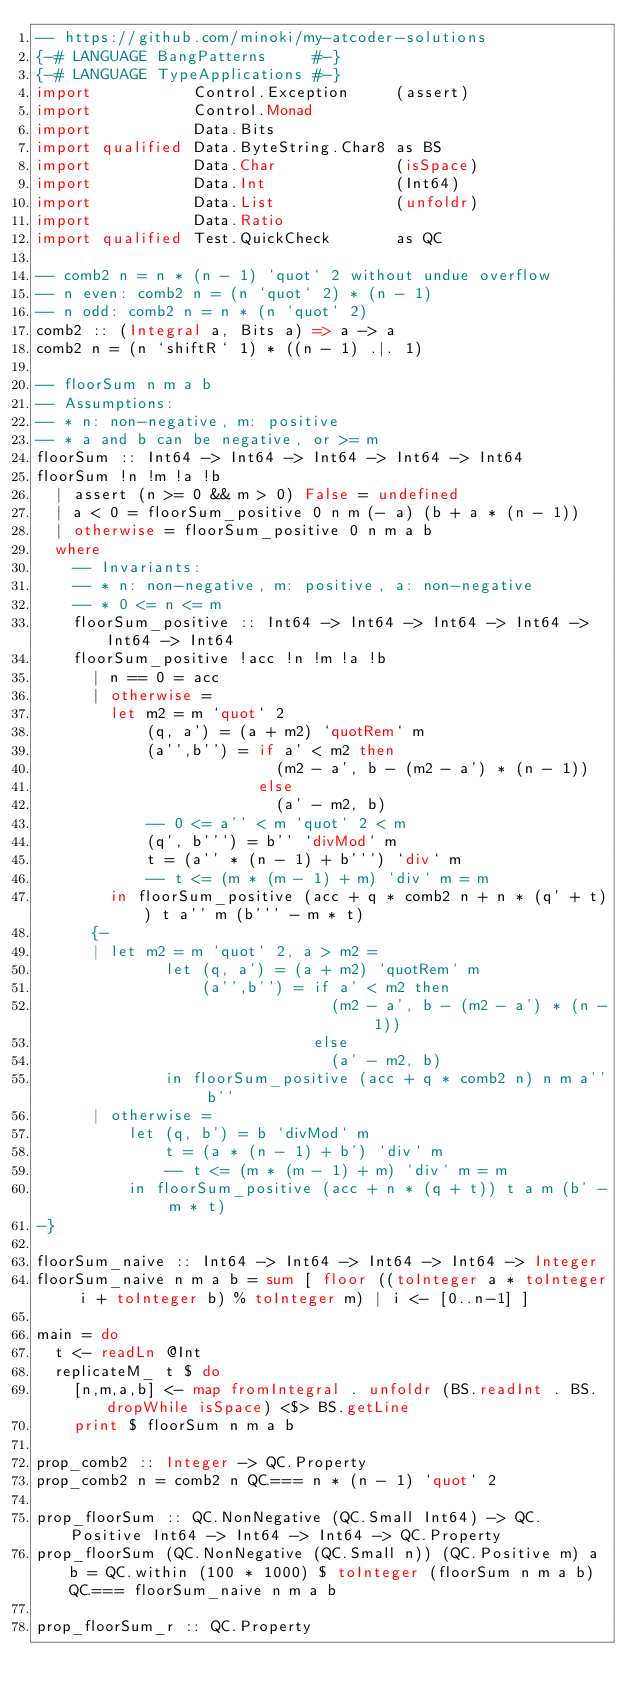<code> <loc_0><loc_0><loc_500><loc_500><_Haskell_>-- https://github.com/minoki/my-atcoder-solutions
{-# LANGUAGE BangPatterns     #-}
{-# LANGUAGE TypeApplications #-}
import           Control.Exception     (assert)
import           Control.Monad
import           Data.Bits
import qualified Data.ByteString.Char8 as BS
import           Data.Char             (isSpace)
import           Data.Int              (Int64)
import           Data.List             (unfoldr)
import           Data.Ratio
import qualified Test.QuickCheck       as QC

-- comb2 n = n * (n - 1) `quot` 2 without undue overflow
-- n even: comb2 n = (n `quot` 2) * (n - 1)
-- n odd: comb2 n = n * (n `quot` 2)
comb2 :: (Integral a, Bits a) => a -> a
comb2 n = (n `shiftR` 1) * ((n - 1) .|. 1)

-- floorSum n m a b
-- Assumptions:
-- * n: non-negative, m: positive
-- * a and b can be negative, or >= m
floorSum :: Int64 -> Int64 -> Int64 -> Int64 -> Int64
floorSum !n !m !a !b
  | assert (n >= 0 && m > 0) False = undefined
  | a < 0 = floorSum_positive 0 n m (- a) (b + a * (n - 1))
  | otherwise = floorSum_positive 0 n m a b
  where
    -- Invariants:
    -- * n: non-negative, m: positive, a: non-negative
    -- * 0 <= n <= m
    floorSum_positive :: Int64 -> Int64 -> Int64 -> Int64 -> Int64 -> Int64
    floorSum_positive !acc !n !m !a !b
      | n == 0 = acc
      | otherwise =
        let m2 = m `quot` 2
            (q, a') = (a + m2) `quotRem` m
            (a'',b'') = if a' < m2 then
                          (m2 - a', b - (m2 - a') * (n - 1))
                        else
                          (a' - m2, b)
            -- 0 <= a'' < m `quot` 2 < m
            (q', b''') = b'' `divMod` m
            t = (a'' * (n - 1) + b''') `div` m
            -- t <= (m * (m - 1) + m) `div` m = m
        in floorSum_positive (acc + q * comb2 n + n * (q' + t)) t a'' m (b''' - m * t)
      {-
      | let m2 = m `quot` 2, a > m2 =
              let (q, a') = (a + m2) `quotRem` m
                  (a'',b'') = if a' < m2 then
                                (m2 - a', b - (m2 - a') * (n - 1))
                              else
                                (a' - m2, b)
              in floorSum_positive (acc + q * comb2 n) n m a'' b''
      | otherwise =
          let (q, b') = b `divMod` m
              t = (a * (n - 1) + b') `div` m
              -- t <= (m * (m - 1) + m) `div` m = m
          in floorSum_positive (acc + n * (q + t)) t a m (b' - m * t)
-}

floorSum_naive :: Int64 -> Int64 -> Int64 -> Int64 -> Integer
floorSum_naive n m a b = sum [ floor ((toInteger a * toInteger i + toInteger b) % toInteger m) | i <- [0..n-1] ]

main = do
  t <- readLn @Int
  replicateM_ t $ do
    [n,m,a,b] <- map fromIntegral . unfoldr (BS.readInt . BS.dropWhile isSpace) <$> BS.getLine
    print $ floorSum n m a b

prop_comb2 :: Integer -> QC.Property
prop_comb2 n = comb2 n QC.=== n * (n - 1) `quot` 2

prop_floorSum :: QC.NonNegative (QC.Small Int64) -> QC.Positive Int64 -> Int64 -> Int64 -> QC.Property
prop_floorSum (QC.NonNegative (QC.Small n)) (QC.Positive m) a b = QC.within (100 * 1000) $ toInteger (floorSum n m a b) QC.=== floorSum_naive n m a b

prop_floorSum_r :: QC.Property</code> 